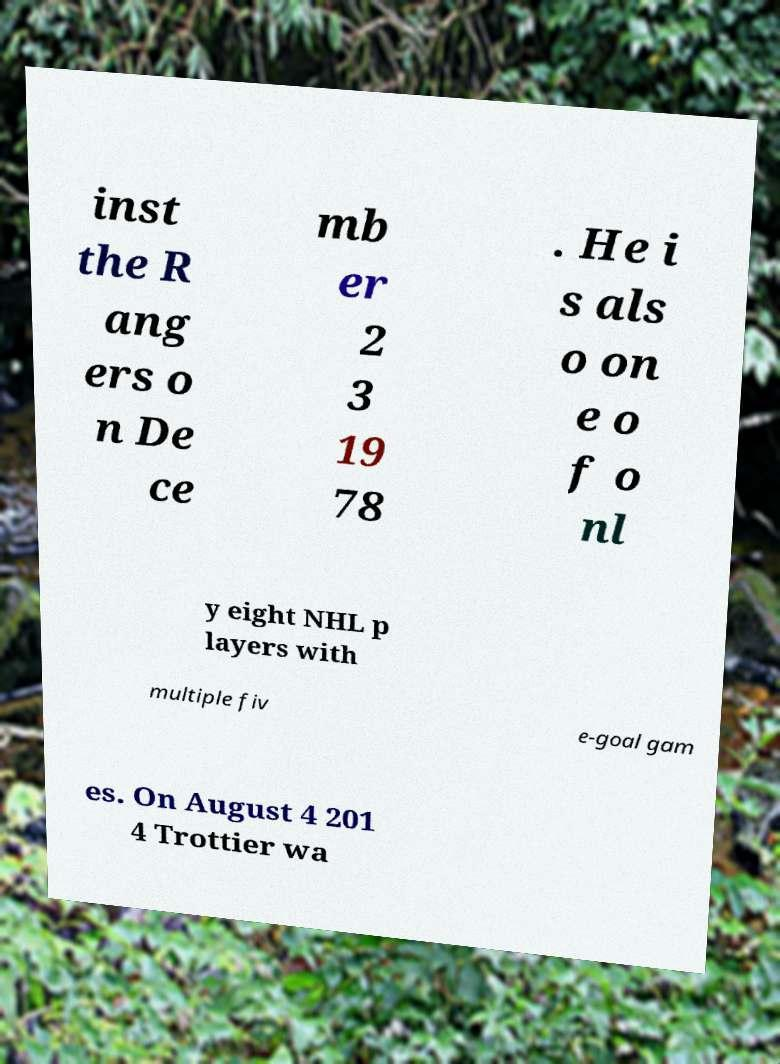Please read and relay the text visible in this image. What does it say? inst the R ang ers o n De ce mb er 2 3 19 78 . He i s als o on e o f o nl y eight NHL p layers with multiple fiv e-goal gam es. On August 4 201 4 Trottier wa 